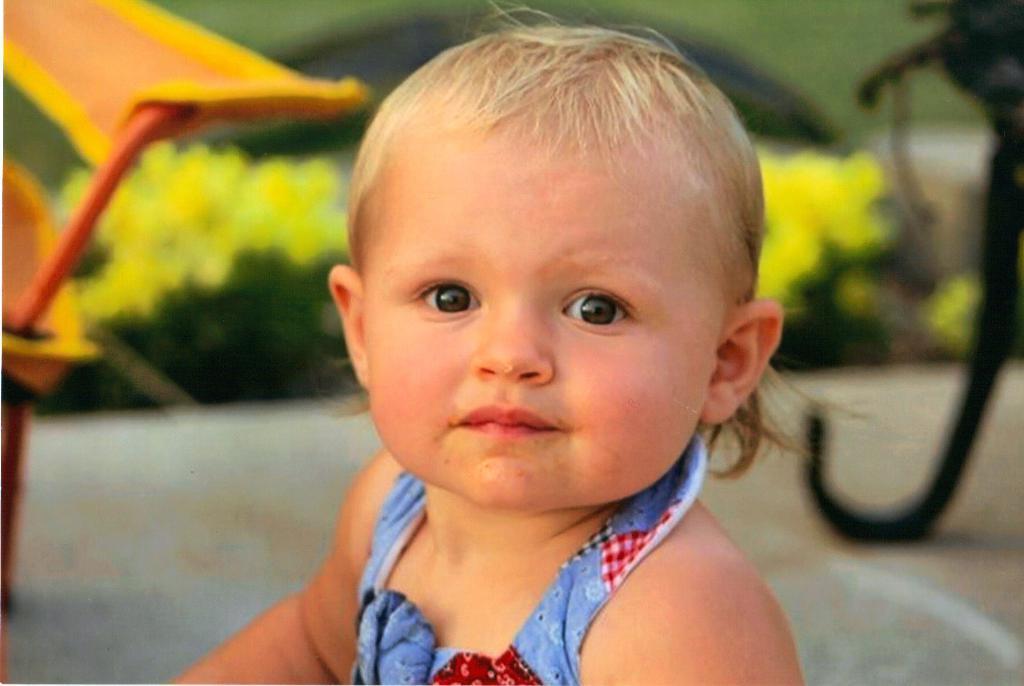In one or two sentences, can you explain what this image depicts? In this image, we can see a baby is watching. Background we can see a blur view. Here we can see plants. Few objects on the surface. 